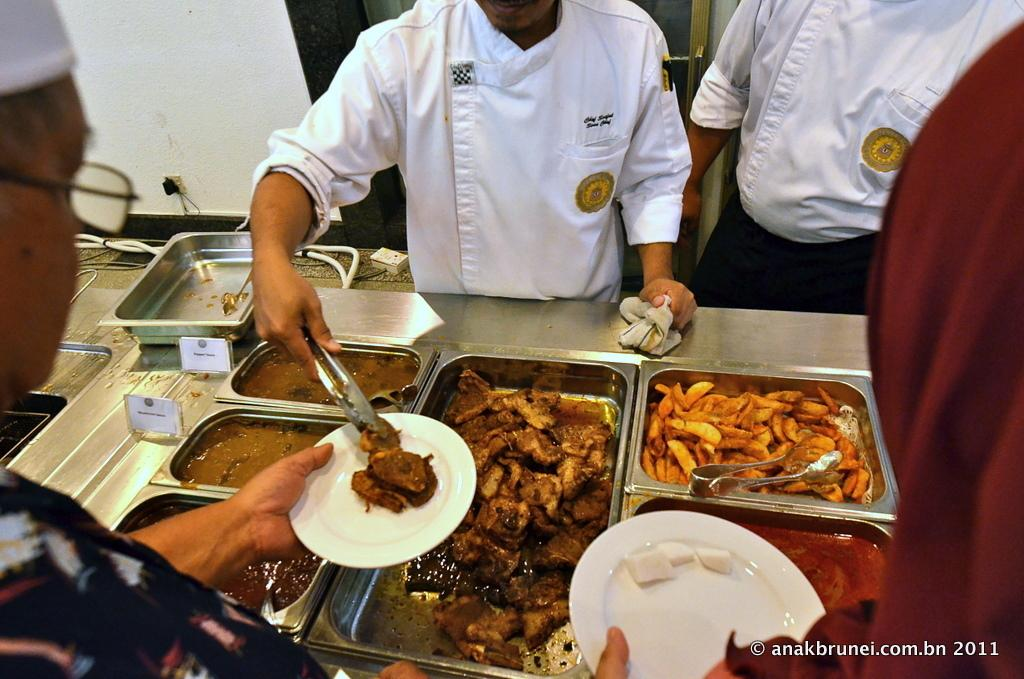What type of containers are used to hold the food in the image? The food is in steel containers in the image. What is the person in the image doing? There is a person serving food in the image. What type of skirt is the carriage wearing in the image? There is no carriage or skirt present in the image. What type of porter is assisting the person serving food in the image? There is no porter present in the image; only the person serving food is visible. 